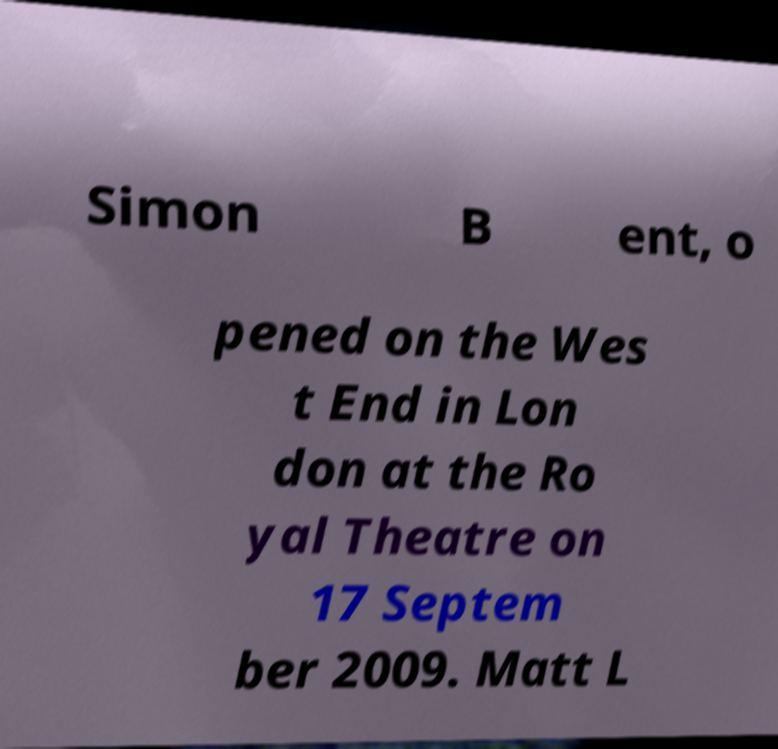There's text embedded in this image that I need extracted. Can you transcribe it verbatim? Simon B ent, o pened on the Wes t End in Lon don at the Ro yal Theatre on 17 Septem ber 2009. Matt L 